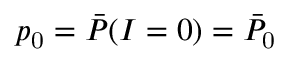<formula> <loc_0><loc_0><loc_500><loc_500>p _ { 0 } = \bar { P } ( I = 0 ) = \bar { P } _ { 0 }</formula> 